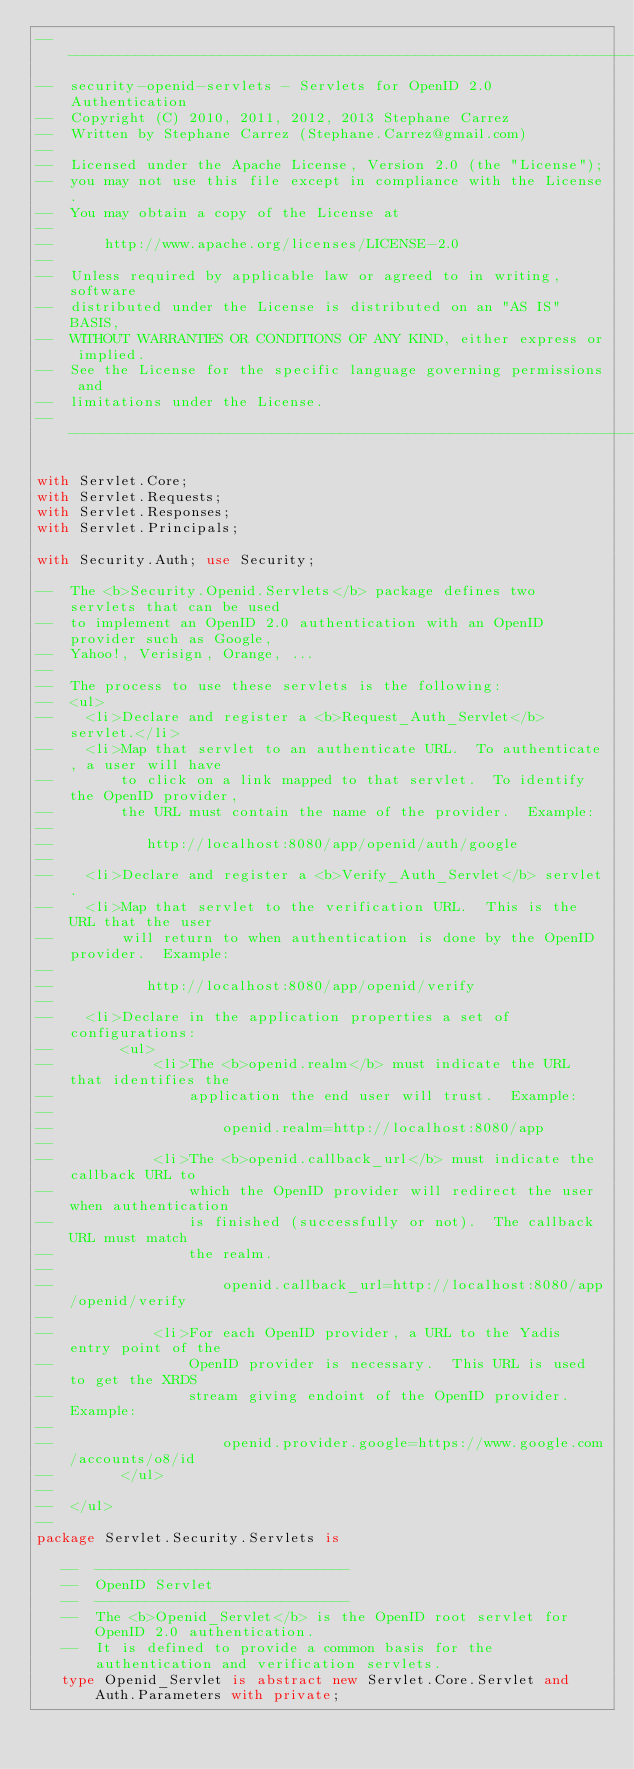<code> <loc_0><loc_0><loc_500><loc_500><_Ada_>-----------------------------------------------------------------------
--  security-openid-servlets - Servlets for OpenID 2.0 Authentication
--  Copyright (C) 2010, 2011, 2012, 2013 Stephane Carrez
--  Written by Stephane Carrez (Stephane.Carrez@gmail.com)
--
--  Licensed under the Apache License, Version 2.0 (the "License");
--  you may not use this file except in compliance with the License.
--  You may obtain a copy of the License at
--
--      http://www.apache.org/licenses/LICENSE-2.0
--
--  Unless required by applicable law or agreed to in writing, software
--  distributed under the License is distributed on an "AS IS" BASIS,
--  WITHOUT WARRANTIES OR CONDITIONS OF ANY KIND, either express or implied.
--  See the License for the specific language governing permissions and
--  limitations under the License.
-----------------------------------------------------------------------

with Servlet.Core;
with Servlet.Requests;
with Servlet.Responses;
with Servlet.Principals;

with Security.Auth; use Security;

--  The <b>Security.Openid.Servlets</b> package defines two servlets that can be used
--  to implement an OpenID 2.0 authentication with an OpenID provider such as Google,
--  Yahoo!, Verisign, Orange, ...
--
--  The process to use these servlets is the following:
--  <ul>
--    <li>Declare and register a <b>Request_Auth_Servlet</b> servlet.</li>
--    <li>Map that servlet to an authenticate URL.  To authenticate, a user will have
--        to click on a link mapped to that servlet.  To identify the OpenID provider,
--        the URL must contain the name of the provider.  Example:
--
--           http://localhost:8080/app/openid/auth/google
--
--    <li>Declare and register a <b>Verify_Auth_Servlet</b> servlet.
--    <li>Map that servlet to the verification URL.  This is the URL that the user
--        will return to when authentication is done by the OpenID provider.  Example:
--
--           http://localhost:8080/app/openid/verify
--
--    <li>Declare in the application properties a set of configurations:
--        <ul>
--            <li>The <b>openid.realm</b> must indicate the URL that identifies the
--                application the end user will trust.  Example:
--
--                    openid.realm=http://localhost:8080/app
--
--            <li>The <b>openid.callback_url</b> must indicate the callback URL to
--                which the OpenID provider will redirect the user when authentication
--                is finished (successfully or not).  The callback URL must match
--                the realm.
--
--                    openid.callback_url=http://localhost:8080/app/openid/verify
--
--            <li>For each OpenID provider, a URL to the Yadis entry point of the
--                OpenID provider is necessary.  This URL is used to get the XRDS
--                stream giving endoint of the OpenID provider.  Example:
--
--                    openid.provider.google=https://www.google.com/accounts/o8/id
--        </ul>
--
--  </ul>
--
package Servlet.Security.Servlets is

   --  ------------------------------
   --  OpenID Servlet
   --  ------------------------------
   --  The <b>Openid_Servlet</b> is the OpenID root servlet for OpenID 2.0 authentication.
   --  It is defined to provide a common basis for the authentication and verification servlets.
   type Openid_Servlet is abstract new Servlet.Core.Servlet and Auth.Parameters with private;
</code> 